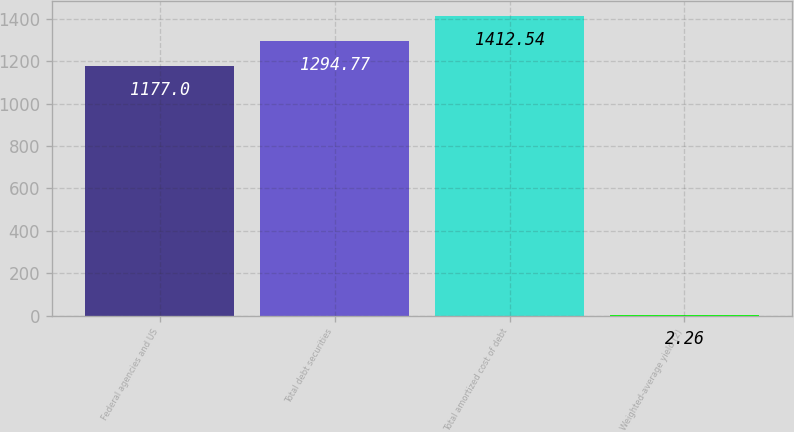Convert chart to OTSL. <chart><loc_0><loc_0><loc_500><loc_500><bar_chart><fcel>Federal agencies and US<fcel>Total debt securities<fcel>Total amortized cost of debt<fcel>Weighted-average yield (2)<nl><fcel>1177<fcel>1294.77<fcel>1412.54<fcel>2.26<nl></chart> 